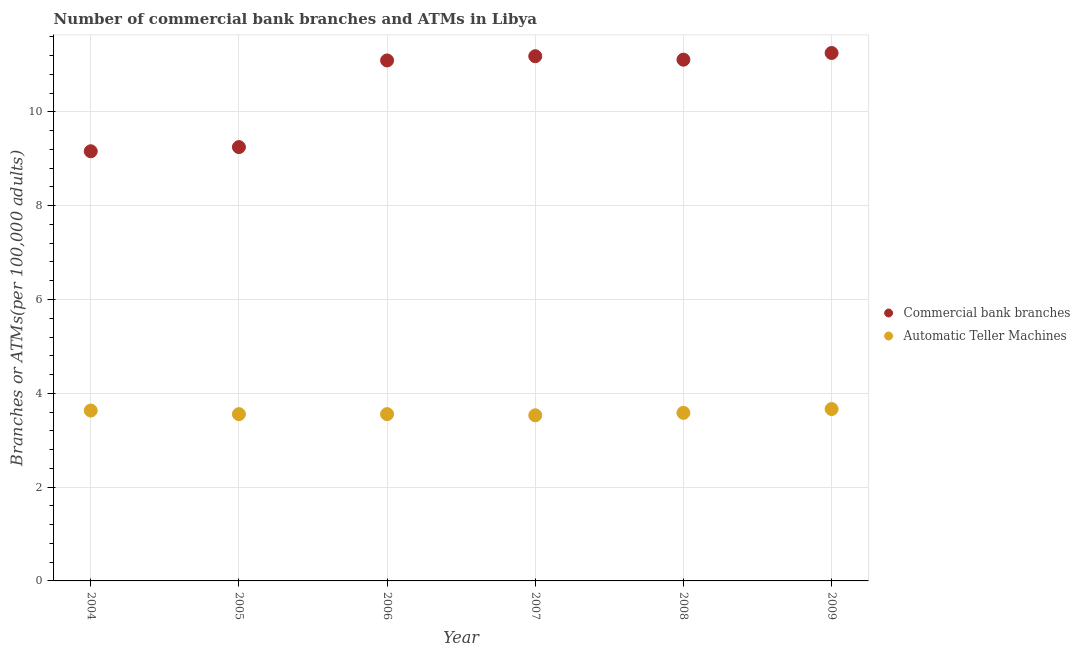How many different coloured dotlines are there?
Your answer should be very brief. 2. Is the number of dotlines equal to the number of legend labels?
Ensure brevity in your answer.  Yes. What is the number of atms in 2006?
Provide a short and direct response. 3.56. Across all years, what is the maximum number of atms?
Make the answer very short. 3.66. Across all years, what is the minimum number of atms?
Keep it short and to the point. 3.53. In which year was the number of commercal bank branches maximum?
Ensure brevity in your answer.  2009. In which year was the number of atms minimum?
Provide a succinct answer. 2007. What is the total number of commercal bank branches in the graph?
Your answer should be very brief. 63.07. What is the difference between the number of commercal bank branches in 2004 and that in 2007?
Offer a very short reply. -2.03. What is the difference between the number of atms in 2008 and the number of commercal bank branches in 2005?
Provide a short and direct response. -5.67. What is the average number of commercal bank branches per year?
Your answer should be compact. 10.51. In the year 2006, what is the difference between the number of commercal bank branches and number of atms?
Offer a very short reply. 7.54. What is the ratio of the number of commercal bank branches in 2006 to that in 2008?
Provide a short and direct response. 1. What is the difference between the highest and the second highest number of commercal bank branches?
Offer a terse response. 0.07. What is the difference between the highest and the lowest number of atms?
Keep it short and to the point. 0.13. In how many years, is the number of commercal bank branches greater than the average number of commercal bank branches taken over all years?
Your response must be concise. 4. Is the sum of the number of commercal bank branches in 2008 and 2009 greater than the maximum number of atms across all years?
Your response must be concise. Yes. Is the number of commercal bank branches strictly greater than the number of atms over the years?
Keep it short and to the point. Yes. How many dotlines are there?
Give a very brief answer. 2. How many years are there in the graph?
Your answer should be very brief. 6. What is the difference between two consecutive major ticks on the Y-axis?
Your response must be concise. 2. Are the values on the major ticks of Y-axis written in scientific E-notation?
Your response must be concise. No. Does the graph contain any zero values?
Offer a very short reply. No. What is the title of the graph?
Keep it short and to the point. Number of commercial bank branches and ATMs in Libya. Does "RDB nonconcessional" appear as one of the legend labels in the graph?
Your answer should be compact. No. What is the label or title of the Y-axis?
Your answer should be compact. Branches or ATMs(per 100,0 adults). What is the Branches or ATMs(per 100,000 adults) in Commercial bank branches in 2004?
Your response must be concise. 9.16. What is the Branches or ATMs(per 100,000 adults) in Automatic Teller Machines in 2004?
Your response must be concise. 3.63. What is the Branches or ATMs(per 100,000 adults) in Commercial bank branches in 2005?
Ensure brevity in your answer.  9.25. What is the Branches or ATMs(per 100,000 adults) in Automatic Teller Machines in 2005?
Provide a succinct answer. 3.56. What is the Branches or ATMs(per 100,000 adults) of Commercial bank branches in 2006?
Provide a succinct answer. 11.1. What is the Branches or ATMs(per 100,000 adults) in Automatic Teller Machines in 2006?
Your response must be concise. 3.56. What is the Branches or ATMs(per 100,000 adults) in Commercial bank branches in 2007?
Your answer should be compact. 11.19. What is the Branches or ATMs(per 100,000 adults) in Automatic Teller Machines in 2007?
Ensure brevity in your answer.  3.53. What is the Branches or ATMs(per 100,000 adults) of Commercial bank branches in 2008?
Provide a short and direct response. 11.11. What is the Branches or ATMs(per 100,000 adults) in Automatic Teller Machines in 2008?
Provide a short and direct response. 3.58. What is the Branches or ATMs(per 100,000 adults) in Commercial bank branches in 2009?
Keep it short and to the point. 11.26. What is the Branches or ATMs(per 100,000 adults) of Automatic Teller Machines in 2009?
Your response must be concise. 3.66. Across all years, what is the maximum Branches or ATMs(per 100,000 adults) of Commercial bank branches?
Keep it short and to the point. 11.26. Across all years, what is the maximum Branches or ATMs(per 100,000 adults) in Automatic Teller Machines?
Offer a very short reply. 3.66. Across all years, what is the minimum Branches or ATMs(per 100,000 adults) in Commercial bank branches?
Provide a succinct answer. 9.16. Across all years, what is the minimum Branches or ATMs(per 100,000 adults) in Automatic Teller Machines?
Keep it short and to the point. 3.53. What is the total Branches or ATMs(per 100,000 adults) in Commercial bank branches in the graph?
Provide a succinct answer. 63.06. What is the total Branches or ATMs(per 100,000 adults) of Automatic Teller Machines in the graph?
Ensure brevity in your answer.  21.52. What is the difference between the Branches or ATMs(per 100,000 adults) in Commercial bank branches in 2004 and that in 2005?
Keep it short and to the point. -0.09. What is the difference between the Branches or ATMs(per 100,000 adults) of Automatic Teller Machines in 2004 and that in 2005?
Offer a very short reply. 0.08. What is the difference between the Branches or ATMs(per 100,000 adults) of Commercial bank branches in 2004 and that in 2006?
Keep it short and to the point. -1.94. What is the difference between the Branches or ATMs(per 100,000 adults) of Automatic Teller Machines in 2004 and that in 2006?
Your answer should be very brief. 0.08. What is the difference between the Branches or ATMs(per 100,000 adults) in Commercial bank branches in 2004 and that in 2007?
Offer a terse response. -2.03. What is the difference between the Branches or ATMs(per 100,000 adults) of Automatic Teller Machines in 2004 and that in 2007?
Offer a terse response. 0.1. What is the difference between the Branches or ATMs(per 100,000 adults) in Commercial bank branches in 2004 and that in 2008?
Your answer should be compact. -1.95. What is the difference between the Branches or ATMs(per 100,000 adults) of Automatic Teller Machines in 2004 and that in 2008?
Give a very brief answer. 0.05. What is the difference between the Branches or ATMs(per 100,000 adults) in Commercial bank branches in 2004 and that in 2009?
Make the answer very short. -2.1. What is the difference between the Branches or ATMs(per 100,000 adults) in Automatic Teller Machines in 2004 and that in 2009?
Give a very brief answer. -0.03. What is the difference between the Branches or ATMs(per 100,000 adults) in Commercial bank branches in 2005 and that in 2006?
Provide a succinct answer. -1.85. What is the difference between the Branches or ATMs(per 100,000 adults) in Automatic Teller Machines in 2005 and that in 2006?
Make the answer very short. -0. What is the difference between the Branches or ATMs(per 100,000 adults) in Commercial bank branches in 2005 and that in 2007?
Keep it short and to the point. -1.94. What is the difference between the Branches or ATMs(per 100,000 adults) of Automatic Teller Machines in 2005 and that in 2007?
Provide a succinct answer. 0.02. What is the difference between the Branches or ATMs(per 100,000 adults) of Commercial bank branches in 2005 and that in 2008?
Your response must be concise. -1.86. What is the difference between the Branches or ATMs(per 100,000 adults) of Automatic Teller Machines in 2005 and that in 2008?
Ensure brevity in your answer.  -0.03. What is the difference between the Branches or ATMs(per 100,000 adults) of Commercial bank branches in 2005 and that in 2009?
Your response must be concise. -2.01. What is the difference between the Branches or ATMs(per 100,000 adults) in Automatic Teller Machines in 2005 and that in 2009?
Make the answer very short. -0.11. What is the difference between the Branches or ATMs(per 100,000 adults) of Commercial bank branches in 2006 and that in 2007?
Offer a terse response. -0.09. What is the difference between the Branches or ATMs(per 100,000 adults) in Automatic Teller Machines in 2006 and that in 2007?
Give a very brief answer. 0.02. What is the difference between the Branches or ATMs(per 100,000 adults) of Commercial bank branches in 2006 and that in 2008?
Your answer should be very brief. -0.02. What is the difference between the Branches or ATMs(per 100,000 adults) in Automatic Teller Machines in 2006 and that in 2008?
Your answer should be compact. -0.03. What is the difference between the Branches or ATMs(per 100,000 adults) in Commercial bank branches in 2006 and that in 2009?
Keep it short and to the point. -0.16. What is the difference between the Branches or ATMs(per 100,000 adults) of Automatic Teller Machines in 2006 and that in 2009?
Make the answer very short. -0.11. What is the difference between the Branches or ATMs(per 100,000 adults) of Commercial bank branches in 2007 and that in 2008?
Your answer should be compact. 0.07. What is the difference between the Branches or ATMs(per 100,000 adults) in Automatic Teller Machines in 2007 and that in 2008?
Your answer should be compact. -0.05. What is the difference between the Branches or ATMs(per 100,000 adults) in Commercial bank branches in 2007 and that in 2009?
Offer a terse response. -0.07. What is the difference between the Branches or ATMs(per 100,000 adults) of Automatic Teller Machines in 2007 and that in 2009?
Provide a succinct answer. -0.13. What is the difference between the Branches or ATMs(per 100,000 adults) of Commercial bank branches in 2008 and that in 2009?
Make the answer very short. -0.14. What is the difference between the Branches or ATMs(per 100,000 adults) of Automatic Teller Machines in 2008 and that in 2009?
Provide a succinct answer. -0.08. What is the difference between the Branches or ATMs(per 100,000 adults) in Commercial bank branches in 2004 and the Branches or ATMs(per 100,000 adults) in Automatic Teller Machines in 2005?
Your answer should be compact. 5.61. What is the difference between the Branches or ATMs(per 100,000 adults) in Commercial bank branches in 2004 and the Branches or ATMs(per 100,000 adults) in Automatic Teller Machines in 2006?
Your response must be concise. 5.6. What is the difference between the Branches or ATMs(per 100,000 adults) of Commercial bank branches in 2004 and the Branches or ATMs(per 100,000 adults) of Automatic Teller Machines in 2007?
Your answer should be very brief. 5.63. What is the difference between the Branches or ATMs(per 100,000 adults) in Commercial bank branches in 2004 and the Branches or ATMs(per 100,000 adults) in Automatic Teller Machines in 2008?
Ensure brevity in your answer.  5.58. What is the difference between the Branches or ATMs(per 100,000 adults) of Commercial bank branches in 2004 and the Branches or ATMs(per 100,000 adults) of Automatic Teller Machines in 2009?
Offer a terse response. 5.5. What is the difference between the Branches or ATMs(per 100,000 adults) of Commercial bank branches in 2005 and the Branches or ATMs(per 100,000 adults) of Automatic Teller Machines in 2006?
Provide a succinct answer. 5.69. What is the difference between the Branches or ATMs(per 100,000 adults) in Commercial bank branches in 2005 and the Branches or ATMs(per 100,000 adults) in Automatic Teller Machines in 2007?
Provide a succinct answer. 5.72. What is the difference between the Branches or ATMs(per 100,000 adults) in Commercial bank branches in 2005 and the Branches or ATMs(per 100,000 adults) in Automatic Teller Machines in 2008?
Provide a short and direct response. 5.67. What is the difference between the Branches or ATMs(per 100,000 adults) in Commercial bank branches in 2005 and the Branches or ATMs(per 100,000 adults) in Automatic Teller Machines in 2009?
Provide a short and direct response. 5.58. What is the difference between the Branches or ATMs(per 100,000 adults) of Commercial bank branches in 2006 and the Branches or ATMs(per 100,000 adults) of Automatic Teller Machines in 2007?
Make the answer very short. 7.57. What is the difference between the Branches or ATMs(per 100,000 adults) in Commercial bank branches in 2006 and the Branches or ATMs(per 100,000 adults) in Automatic Teller Machines in 2008?
Ensure brevity in your answer.  7.51. What is the difference between the Branches or ATMs(per 100,000 adults) in Commercial bank branches in 2006 and the Branches or ATMs(per 100,000 adults) in Automatic Teller Machines in 2009?
Make the answer very short. 7.43. What is the difference between the Branches or ATMs(per 100,000 adults) in Commercial bank branches in 2007 and the Branches or ATMs(per 100,000 adults) in Automatic Teller Machines in 2008?
Provide a succinct answer. 7.6. What is the difference between the Branches or ATMs(per 100,000 adults) in Commercial bank branches in 2007 and the Branches or ATMs(per 100,000 adults) in Automatic Teller Machines in 2009?
Provide a succinct answer. 7.52. What is the difference between the Branches or ATMs(per 100,000 adults) of Commercial bank branches in 2008 and the Branches or ATMs(per 100,000 adults) of Automatic Teller Machines in 2009?
Your answer should be very brief. 7.45. What is the average Branches or ATMs(per 100,000 adults) of Commercial bank branches per year?
Offer a very short reply. 10.51. What is the average Branches or ATMs(per 100,000 adults) in Automatic Teller Machines per year?
Offer a terse response. 3.59. In the year 2004, what is the difference between the Branches or ATMs(per 100,000 adults) of Commercial bank branches and Branches or ATMs(per 100,000 adults) of Automatic Teller Machines?
Your answer should be very brief. 5.53. In the year 2005, what is the difference between the Branches or ATMs(per 100,000 adults) of Commercial bank branches and Branches or ATMs(per 100,000 adults) of Automatic Teller Machines?
Your answer should be very brief. 5.69. In the year 2006, what is the difference between the Branches or ATMs(per 100,000 adults) in Commercial bank branches and Branches or ATMs(per 100,000 adults) in Automatic Teller Machines?
Ensure brevity in your answer.  7.54. In the year 2007, what is the difference between the Branches or ATMs(per 100,000 adults) in Commercial bank branches and Branches or ATMs(per 100,000 adults) in Automatic Teller Machines?
Offer a terse response. 7.66. In the year 2008, what is the difference between the Branches or ATMs(per 100,000 adults) of Commercial bank branches and Branches or ATMs(per 100,000 adults) of Automatic Teller Machines?
Your response must be concise. 7.53. In the year 2009, what is the difference between the Branches or ATMs(per 100,000 adults) of Commercial bank branches and Branches or ATMs(per 100,000 adults) of Automatic Teller Machines?
Provide a short and direct response. 7.59. What is the ratio of the Branches or ATMs(per 100,000 adults) in Automatic Teller Machines in 2004 to that in 2005?
Make the answer very short. 1.02. What is the ratio of the Branches or ATMs(per 100,000 adults) in Commercial bank branches in 2004 to that in 2006?
Make the answer very short. 0.83. What is the ratio of the Branches or ATMs(per 100,000 adults) of Automatic Teller Machines in 2004 to that in 2006?
Provide a short and direct response. 1.02. What is the ratio of the Branches or ATMs(per 100,000 adults) of Commercial bank branches in 2004 to that in 2007?
Make the answer very short. 0.82. What is the ratio of the Branches or ATMs(per 100,000 adults) in Automatic Teller Machines in 2004 to that in 2007?
Give a very brief answer. 1.03. What is the ratio of the Branches or ATMs(per 100,000 adults) in Commercial bank branches in 2004 to that in 2008?
Make the answer very short. 0.82. What is the ratio of the Branches or ATMs(per 100,000 adults) in Automatic Teller Machines in 2004 to that in 2008?
Keep it short and to the point. 1.01. What is the ratio of the Branches or ATMs(per 100,000 adults) in Commercial bank branches in 2004 to that in 2009?
Provide a short and direct response. 0.81. What is the ratio of the Branches or ATMs(per 100,000 adults) of Automatic Teller Machines in 2004 to that in 2009?
Your response must be concise. 0.99. What is the ratio of the Branches or ATMs(per 100,000 adults) of Commercial bank branches in 2005 to that in 2006?
Your answer should be compact. 0.83. What is the ratio of the Branches or ATMs(per 100,000 adults) in Automatic Teller Machines in 2005 to that in 2006?
Ensure brevity in your answer.  1. What is the ratio of the Branches or ATMs(per 100,000 adults) of Commercial bank branches in 2005 to that in 2007?
Make the answer very short. 0.83. What is the ratio of the Branches or ATMs(per 100,000 adults) in Automatic Teller Machines in 2005 to that in 2007?
Provide a short and direct response. 1.01. What is the ratio of the Branches or ATMs(per 100,000 adults) of Commercial bank branches in 2005 to that in 2008?
Your answer should be very brief. 0.83. What is the ratio of the Branches or ATMs(per 100,000 adults) in Automatic Teller Machines in 2005 to that in 2008?
Give a very brief answer. 0.99. What is the ratio of the Branches or ATMs(per 100,000 adults) of Commercial bank branches in 2005 to that in 2009?
Your answer should be very brief. 0.82. What is the ratio of the Branches or ATMs(per 100,000 adults) of Automatic Teller Machines in 2005 to that in 2009?
Make the answer very short. 0.97. What is the ratio of the Branches or ATMs(per 100,000 adults) in Commercial bank branches in 2006 to that in 2009?
Keep it short and to the point. 0.99. What is the ratio of the Branches or ATMs(per 100,000 adults) of Automatic Teller Machines in 2006 to that in 2009?
Make the answer very short. 0.97. What is the ratio of the Branches or ATMs(per 100,000 adults) of Commercial bank branches in 2007 to that in 2008?
Provide a short and direct response. 1.01. What is the ratio of the Branches or ATMs(per 100,000 adults) of Automatic Teller Machines in 2007 to that in 2008?
Your response must be concise. 0.99. What is the ratio of the Branches or ATMs(per 100,000 adults) in Automatic Teller Machines in 2007 to that in 2009?
Offer a very short reply. 0.96. What is the ratio of the Branches or ATMs(per 100,000 adults) in Commercial bank branches in 2008 to that in 2009?
Offer a very short reply. 0.99. What is the ratio of the Branches or ATMs(per 100,000 adults) in Automatic Teller Machines in 2008 to that in 2009?
Provide a short and direct response. 0.98. What is the difference between the highest and the second highest Branches or ATMs(per 100,000 adults) of Commercial bank branches?
Your answer should be compact. 0.07. What is the difference between the highest and the second highest Branches or ATMs(per 100,000 adults) of Automatic Teller Machines?
Provide a succinct answer. 0.03. What is the difference between the highest and the lowest Branches or ATMs(per 100,000 adults) in Commercial bank branches?
Your response must be concise. 2.1. What is the difference between the highest and the lowest Branches or ATMs(per 100,000 adults) of Automatic Teller Machines?
Your response must be concise. 0.13. 